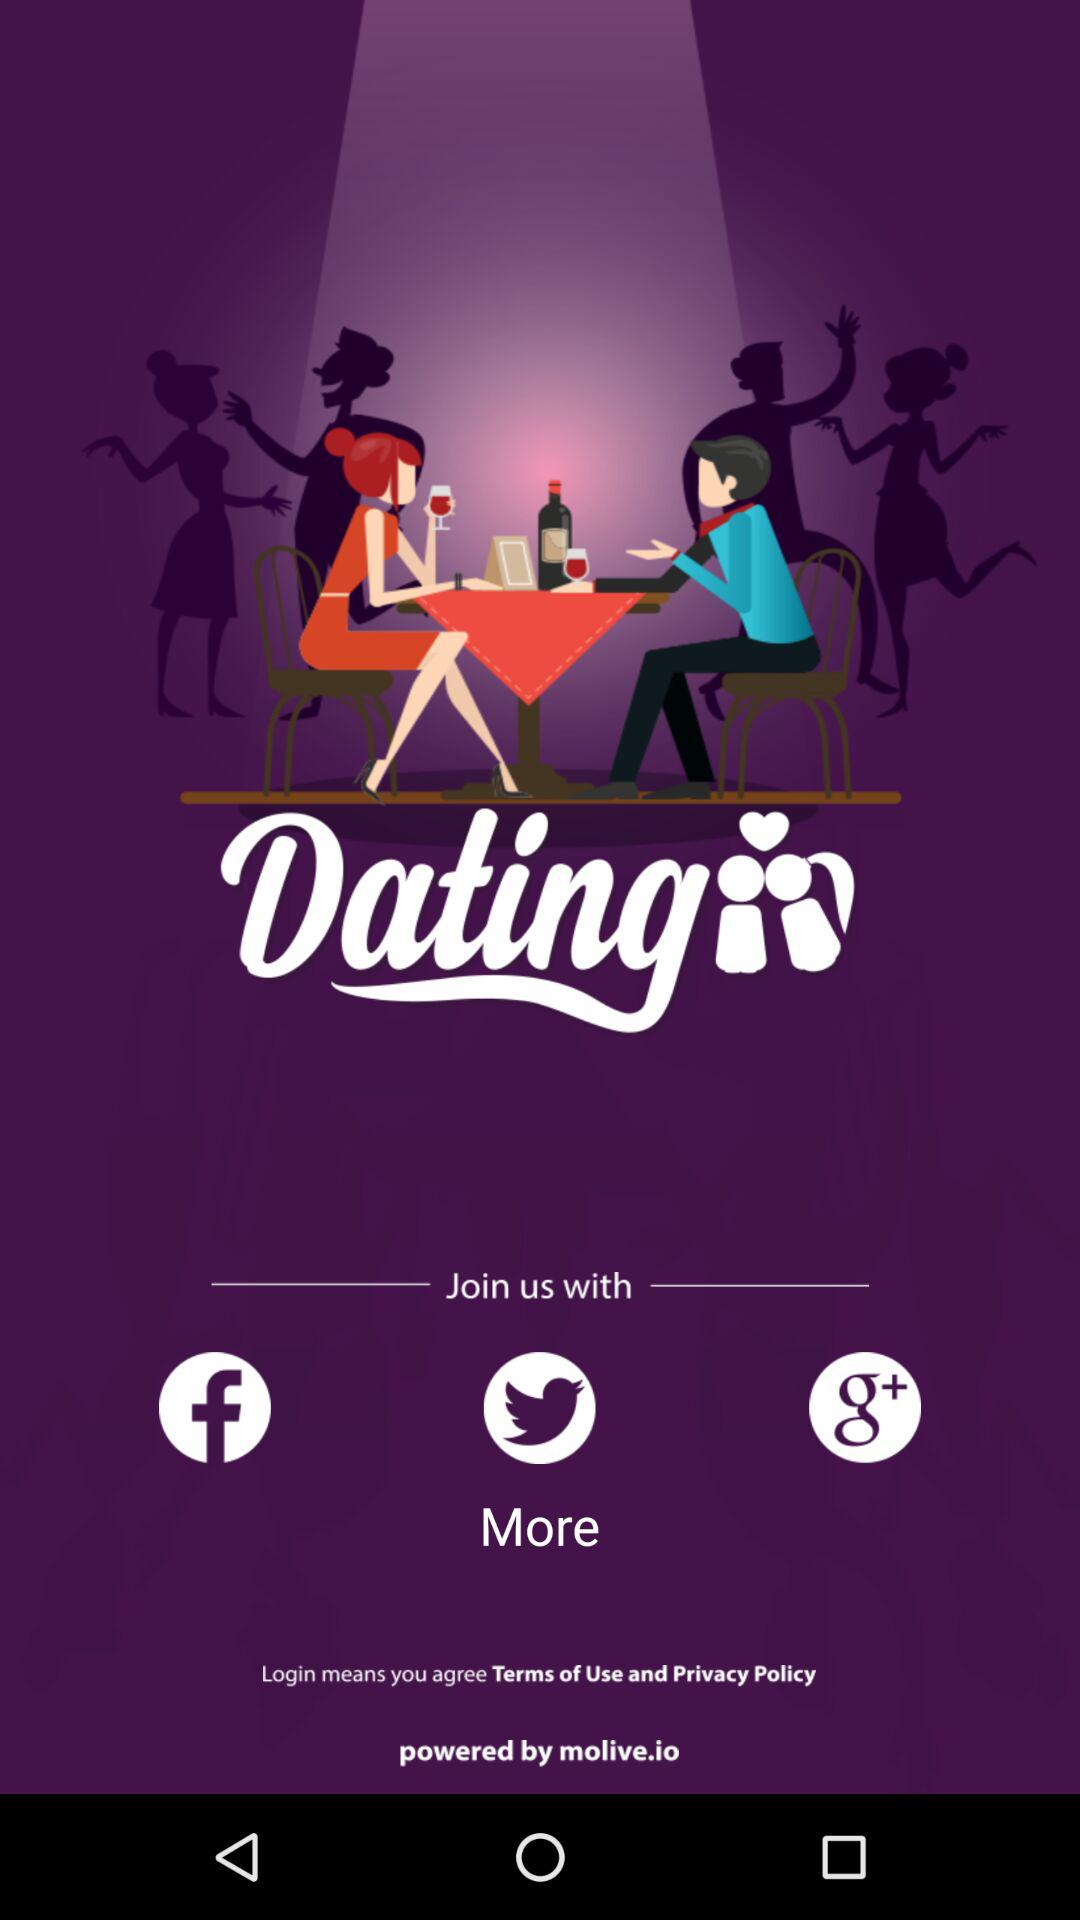Which applications can be used to join? The applications that can be used to join are "Facebook", "Twitter" and "Google+". 